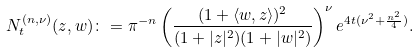Convert formula to latex. <formula><loc_0><loc_0><loc_500><loc_500>N _ { t } ^ { ( n , \nu ) } ( z , w ) \colon = \pi ^ { - n } \left ( \frac { ( 1 + \langle w , z \rangle ) ^ { 2 } } { ( 1 + | z | ^ { 2 } ) ( 1 + | w | ^ { 2 } ) } \right ) ^ { \nu } e ^ { 4 t ( \nu ^ { 2 } + \frac { n ^ { 2 } } { 4 } ) } .</formula> 